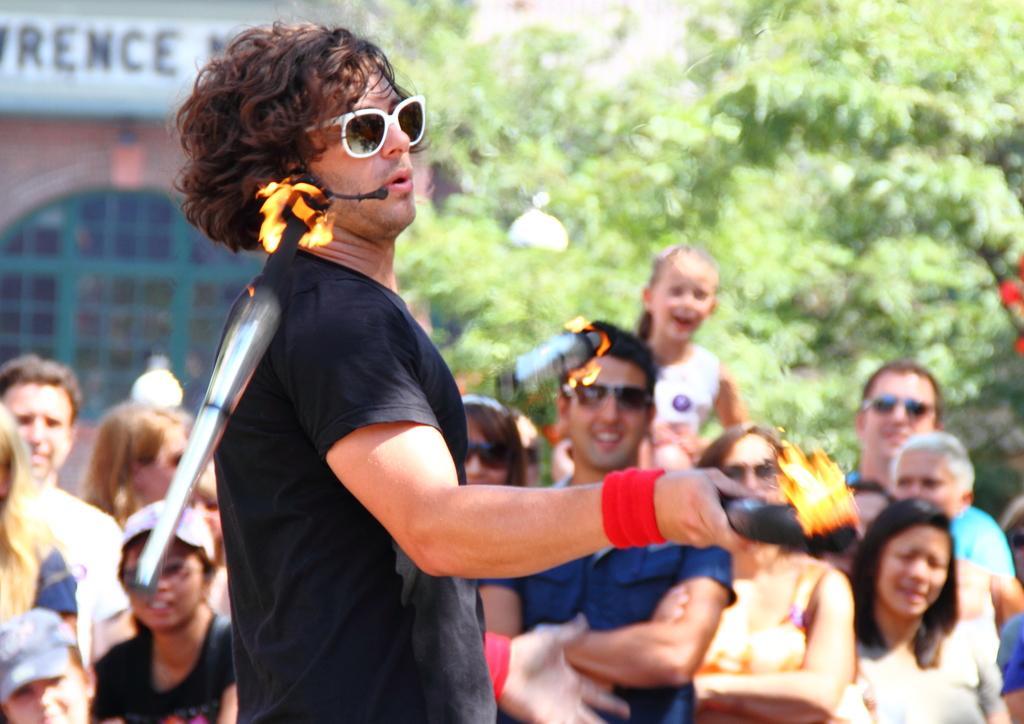Could you give a brief overview of what you see in this image? In this image I can see a person playing juggling with fire lamps. I can see few persons standing. In the background I can see few trees and a building. 